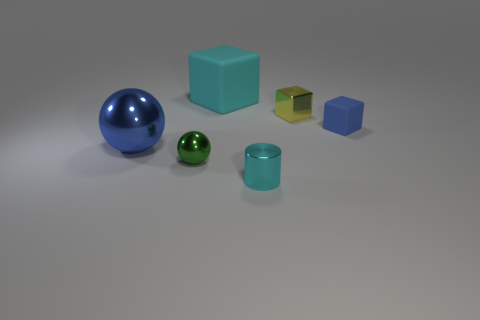The green metal thing that is the same size as the metal cylinder is what shape?
Provide a short and direct response. Sphere. There is a metal object behind the tiny rubber thing; what is its color?
Provide a succinct answer. Yellow. There is a cyan object behind the green object; are there any shiny blocks that are behind it?
Offer a terse response. No. How many things are either things behind the blue matte cube or tiny metal spheres?
Your answer should be very brief. 3. Is there anything else that is the same size as the green ball?
Offer a terse response. Yes. What material is the large object to the left of the block that is to the left of the small metallic block made of?
Provide a succinct answer. Metal. Are there an equal number of small cubes behind the yellow metal thing and tiny green metal balls that are left of the small cylinder?
Offer a very short reply. No. How many things are either matte blocks that are in front of the tiny yellow cube or cyan blocks behind the small green shiny thing?
Keep it short and to the point. 2. The tiny object that is behind the tiny green object and in front of the tiny yellow block is made of what material?
Your answer should be very brief. Rubber. There is a block that is on the left side of the cyan object in front of the block on the left side of the metal cylinder; how big is it?
Give a very brief answer. Large. 